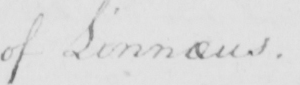Can you read and transcribe this handwriting? of Linnaeus  . 